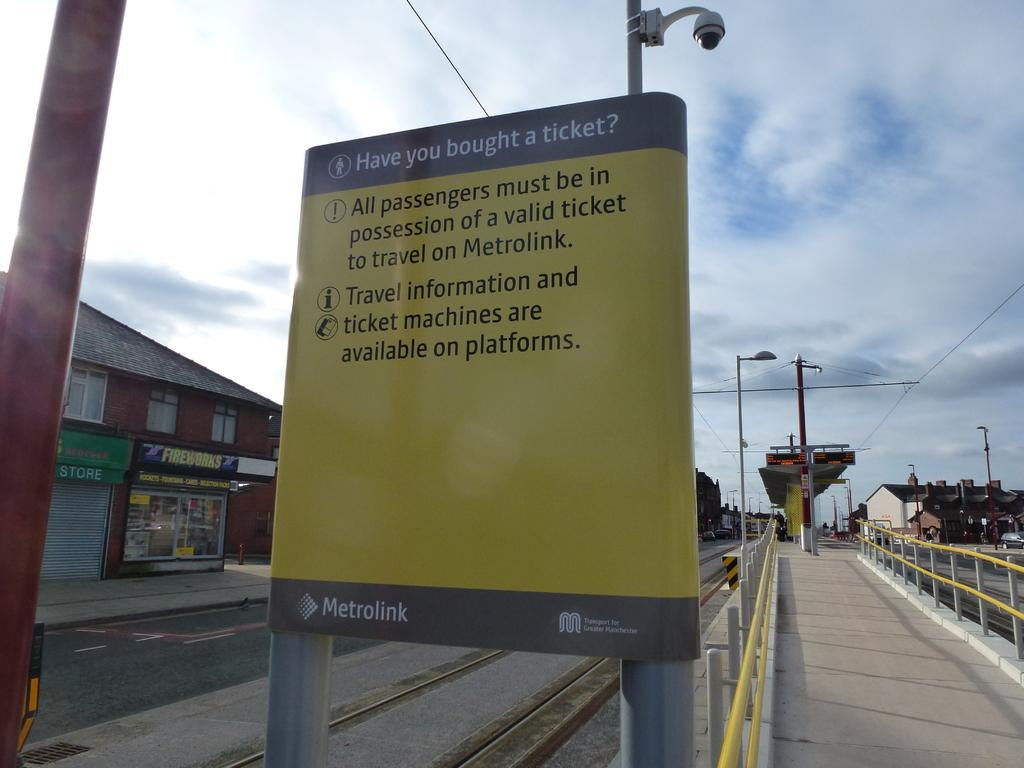<image>
Describe the image concisely. Metrolink has a sign displayed about their ticket information. 